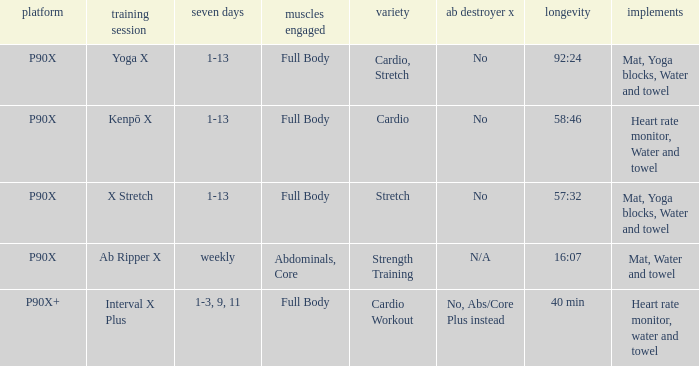How many types are cardio? 1.0. 